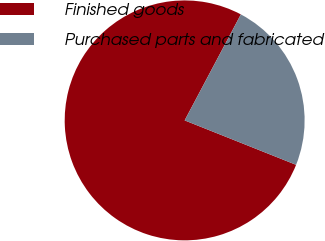<chart> <loc_0><loc_0><loc_500><loc_500><pie_chart><fcel>Finished goods<fcel>Purchased parts and fabricated<nl><fcel>76.72%<fcel>23.28%<nl></chart> 